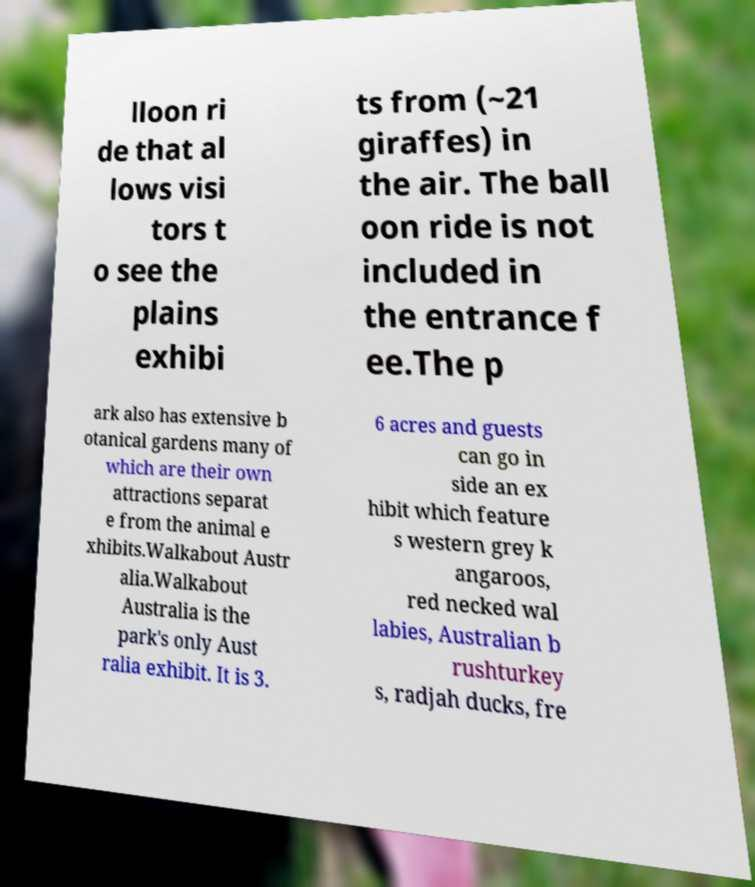Please identify and transcribe the text found in this image. lloon ri de that al lows visi tors t o see the plains exhibi ts from (~21 giraffes) in the air. The ball oon ride is not included in the entrance f ee.The p ark also has extensive b otanical gardens many of which are their own attractions separat e from the animal e xhibits.Walkabout Austr alia.Walkabout Australia is the park's only Aust ralia exhibit. It is 3. 6 acres and guests can go in side an ex hibit which feature s western grey k angaroos, red necked wal labies, Australian b rushturkey s, radjah ducks, fre 